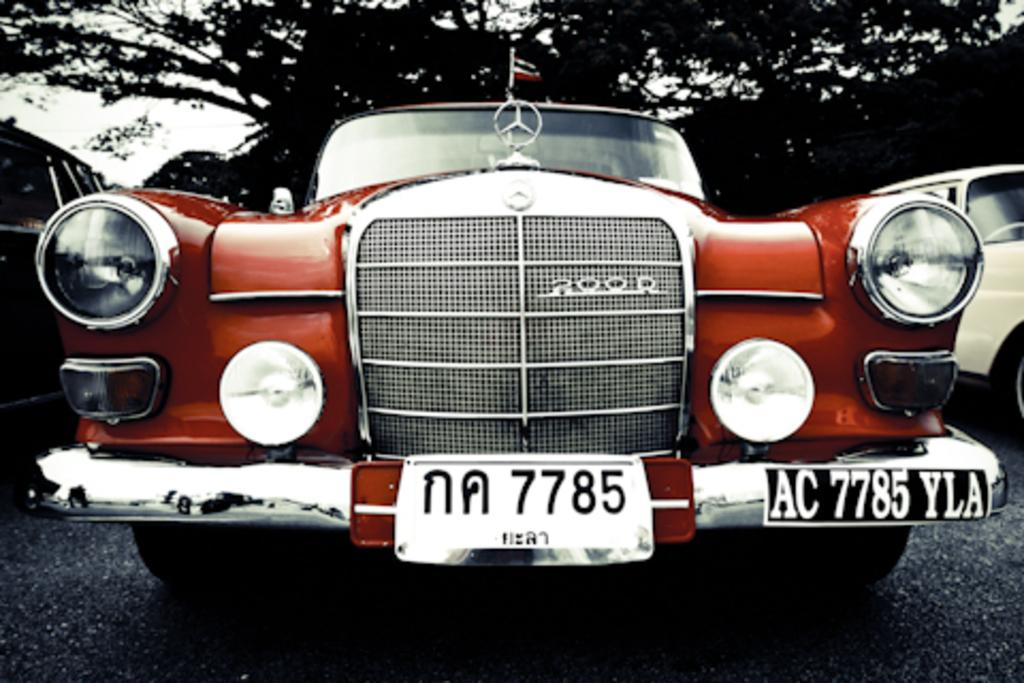What can be seen on the road in the image? There are cars parked on the road in the image. What is visible behind the parked cars? There are trees visible behind the parked cars. Where is the doctor's office located in the image? There is no doctor's office present in the image; it only features parked cars and trees. What type of rail is visible in the image? There is no rail present in the image; it only features parked cars and trees. 